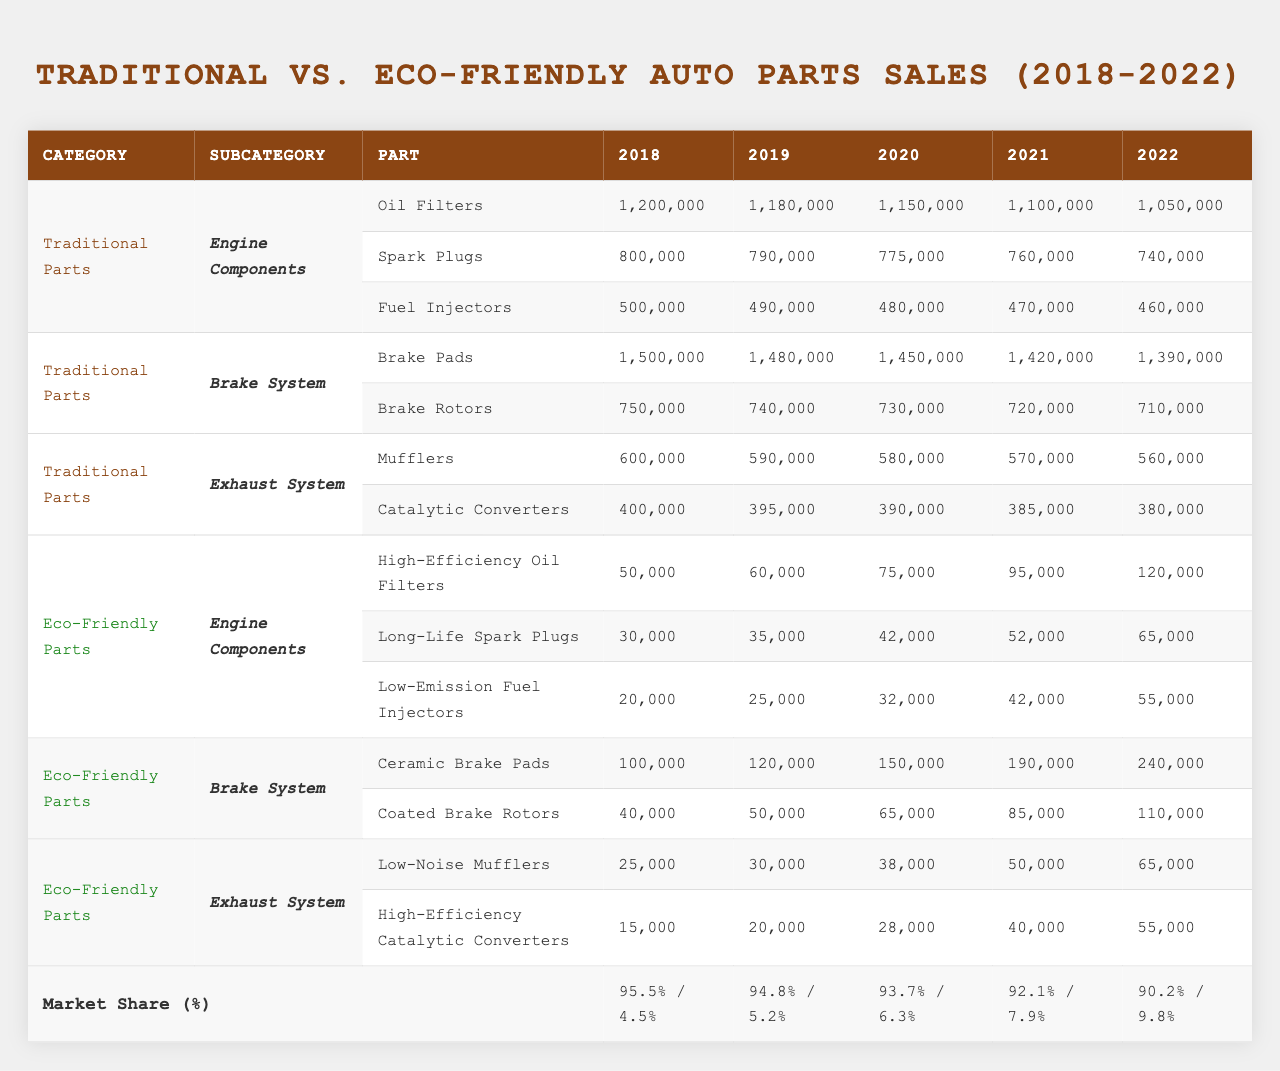What was the total sales of Brake Pads in 2022 for Traditional Parts? The sales for Brake Pads in 2022 are 1,390,000 units. This value can be directly retrieved from the table under the Traditional Parts and Brake System category for 2022.
Answer: 1,390,000 How much did the sales of Long-Life Spark Plugs increase from 2018 to 2022? The sales for Long-Life Spark Plugs in 2018 are 30,000, and in 2022, they are 65,000. The increase is calculated as 65,000 - 30,000 = 35,000 units.
Answer: 35,000 What was the market share of Eco-Friendly Parts in 2020? The market share of Eco-Friendly Parts in 2020 is listed as 6.3%. This information can be found in the Market Share section of the table for that year.
Answer: 6.3% Which category had the highest sales in 2021, and what was the value? By examining the sales for each category in 2021, Brake Pads from Traditional Parts had the highest sales at 1,420,000 units. This is greater than both Eco-Friendly and other Traditional categories.
Answer: Brake Pads; 1,420,000 Was the average price of High-Efficiency Oil Filters decreasing over the years? The average prices for High-Efficiency Oil Filters from 2018 to 2022 are 25, 24, 23, 22, and 21 dollars respectively. The prices are consistently decreasing each year, confirming that the average price is decreasing.
Answer: Yes What is the difference in sales for Ceramic Brake Pads between 2018 and 2022? The sales of Ceramic Brake Pads in 2018 were 100,000 and in 2022 it was 240,000. The difference is calculated by 240,000 - 100,000 = 140,000 units.
Answer: 140,000 In which year did the sales of Engine Components for Eco-Friendly Parts exceed 150,000 units? By reviewing the sales for each Engine Component under Eco-Friendly Parts, in 2022, the sales of High-Efficiency Oil Filters, Long-Life Spark Plugs, and Low-Emission Fuel Injectors sum to 120,000 + 65,000 + 55,000 = 240,000 units which exceeds 150,000. Therefore, the year is 2022.
Answer: 2022 What were the total sales for Traditional Engine Components in 2020? To get the total sales for traditional Engine Components in 2020, we sum the individual components: Oil Filters (1,150,000) + Spark Plugs (775,000) + Fuel Injectors (480,000) = 2,405,000.
Answer: 2,405,000 Was the market share of Traditional Parts ever below 90%? According to the data, the market share of Traditional Parts in 2022 is 90.2%. Since this is above 90%, the statement is false; Traditional Parts were never below 90%.
Answer: No In what year did Eco-Friendly Brake Pads first surpass 150,000 units in sales? The sales for Eco-Friendly Ceramic Brake Pads were 100,000 in 2018, 120,000 in 2019, and increased to 150,000 in 2020. Thus, 2020 is the year they first surpassed this threshold.
Answer: 2020 